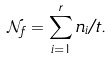<formula> <loc_0><loc_0><loc_500><loc_500>\mathcal { N } _ { f } = \sum _ { i = 1 } ^ { r } n _ { i } / t .</formula> 